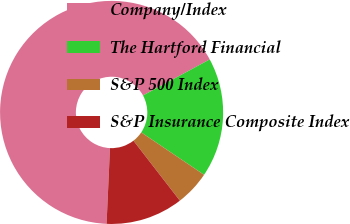Convert chart to OTSL. <chart><loc_0><loc_0><loc_500><loc_500><pie_chart><fcel>Company/Index<fcel>The Hartford Financial<fcel>S&P 500 Index<fcel>S&P Insurance Composite Index<nl><fcel>66.4%<fcel>17.33%<fcel>5.07%<fcel>11.2%<nl></chart> 